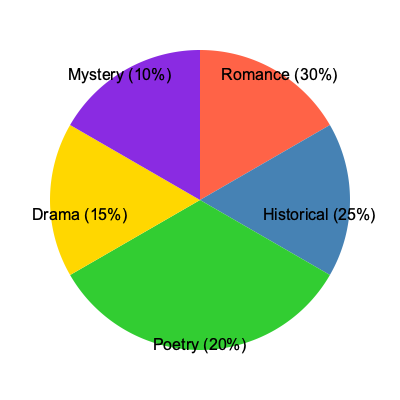Based on the pie chart depicting the distribution of literary genres in French television shows from the 1960s-1980s, which genre dominated the airwaves, and what percentage of the total did it represent? To answer this question, we need to analyze the pie chart carefully:

1. The chart shows five literary genres: Romance, Historical, Poetry, Drama, and Mystery.

2. Each genre is represented by a different color and labeled with its percentage.

3. The percentages for each genre are:
   - Romance: 30%
   - Historical: 25%
   - Poetry: 20%
   - Drama: 15%
   - Mystery: 10%

4. To determine which genre dominated, we need to identify the largest percentage.

5. Comparing the percentages, we can see that Romance has the highest at 30%.

Therefore, Romance was the dominant genre in French television shows about literature during the 1960s-1980s, representing 30% of the total.
Answer: Romance, 30% 